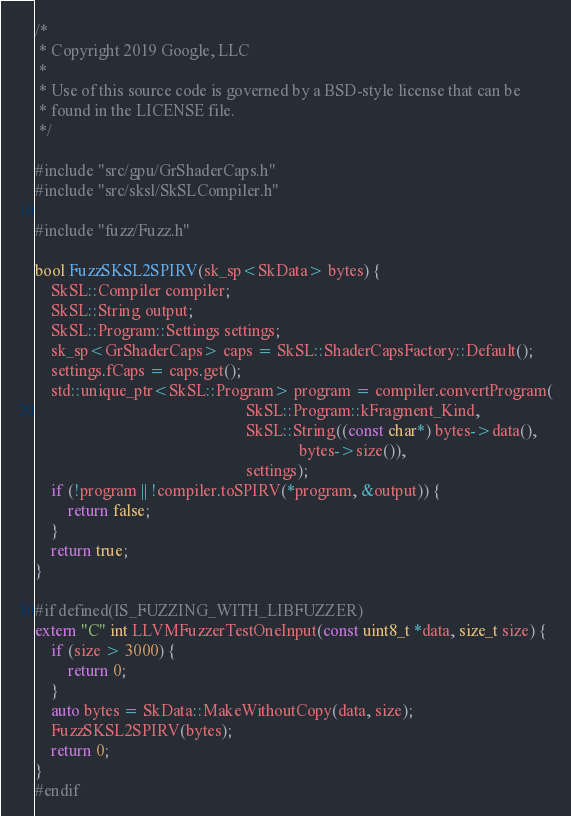<code> <loc_0><loc_0><loc_500><loc_500><_C++_>/*
 * Copyright 2019 Google, LLC
 *
 * Use of this source code is governed by a BSD-style license that can be
 * found in the LICENSE file.
 */

#include "src/gpu/GrShaderCaps.h"
#include "src/sksl/SkSLCompiler.h"

#include "fuzz/Fuzz.h"

bool FuzzSKSL2SPIRV(sk_sp<SkData> bytes) {
    SkSL::Compiler compiler;
    SkSL::String output;
    SkSL::Program::Settings settings;
    sk_sp<GrShaderCaps> caps = SkSL::ShaderCapsFactory::Default();
    settings.fCaps = caps.get();
    std::unique_ptr<SkSL::Program> program = compiler.convertProgram(
                                                    SkSL::Program::kFragment_Kind,
                                                    SkSL::String((const char*) bytes->data(),
                                                                 bytes->size()),
                                                    settings);
    if (!program || !compiler.toSPIRV(*program, &output)) {
        return false;
    }
    return true;
}

#if defined(IS_FUZZING_WITH_LIBFUZZER)
extern "C" int LLVMFuzzerTestOneInput(const uint8_t *data, size_t size) {
    if (size > 3000) {
        return 0;
    }
    auto bytes = SkData::MakeWithoutCopy(data, size);
    FuzzSKSL2SPIRV(bytes);
    return 0;
}
#endif
</code> 